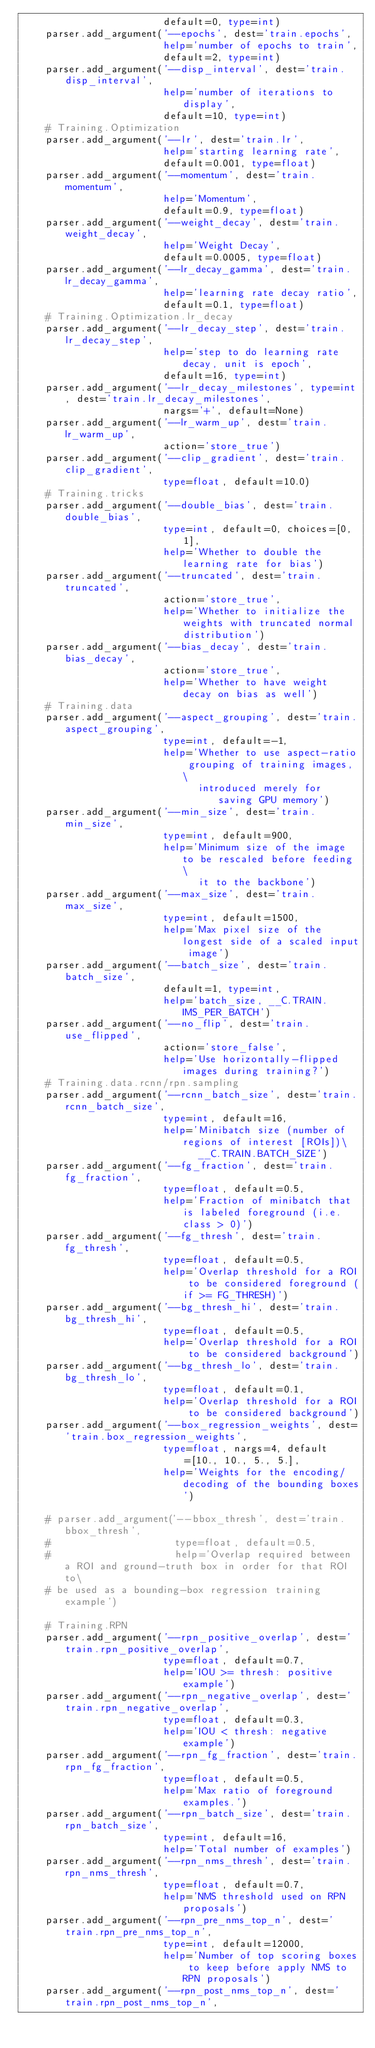Convert code to text. <code><loc_0><loc_0><loc_500><loc_500><_Python_>                        default=0, type=int)
    parser.add_argument('--epochs', dest='train.epochs',
                        help='number of epochs to train',
                        default=2, type=int)
    parser.add_argument('--disp_interval', dest='train.disp_interval',
                        help='number of iterations to display',
                        default=10, type=int)
    # Training.Optimization
    parser.add_argument('--lr', dest='train.lr',
                        help='starting learning rate',
                        default=0.001, type=float)
    parser.add_argument('--momentum', dest='train.momentum',
                        help='Momentum',
                        default=0.9, type=float)
    parser.add_argument('--weight_decay', dest='train.weight_decay',
                        help='Weight Decay',
                        default=0.0005, type=float)
    parser.add_argument('--lr_decay_gamma', dest='train.lr_decay_gamma',
                        help='learning rate decay ratio',
                        default=0.1, type=float)
    # Training.Optimization.lr_decay
    parser.add_argument('--lr_decay_step', dest='train.lr_decay_step',
                        help='step to do learning rate decay, unit is epoch',
                        default=16, type=int)
    parser.add_argument('--lr_decay_milestones', type=int, dest='train.lr_decay_milestones',
                        nargs='+', default=None)
    parser.add_argument('--lr_warm_up', dest='train.lr_warm_up',
                        action='store_true')
    parser.add_argument('--clip_gradient', dest='train.clip_gradient',
                        type=float, default=10.0)
    # Training.tricks
    parser.add_argument('--double_bias', dest='train.double_bias',
                        type=int, default=0, choices=[0, 1],
                        help='Whether to double the learning rate for bias')
    parser.add_argument('--truncated', dest='train.truncated',
                        action='store_true',
                        help='Whether to initialize the weights with truncated normal distribution')
    parser.add_argument('--bias_decay', dest='train.bias_decay',
                        action='store_true',
                        help='Whether to have weight decay on bias as well')
    # Training.data
    parser.add_argument('--aspect_grouping', dest='train.aspect_grouping',
                        type=int, default=-1,
                        help='Whether to use aspect-ratio grouping of training images, \
                              introduced merely for saving GPU memory')
    parser.add_argument('--min_size', dest='train.min_size',
                        type=int, default=900,
                        help='Minimum size of the image to be rescaled before feeding \
                              it to the backbone')
    parser.add_argument('--max_size', dest='train.max_size',
                        type=int, default=1500,
                        help='Max pixel size of the longest side of a scaled input image')
    parser.add_argument('--batch_size', dest='train.batch_size',
                        default=1, type=int,
                        help='batch_size, __C.TRAIN.IMS_PER_BATCH')
    parser.add_argument('--no_flip', dest='train.use_flipped',
                        action='store_false',
                        help='Use horizontally-flipped images during training?')
    # Training.data.rcnn/rpn.sampling
    parser.add_argument('--rcnn_batch_size', dest='train.rcnn_batch_size',
                        type=int, default=16,
                        help='Minibatch size (number of regions of interest [ROIs])\
                              __C.TRAIN.BATCH_SIZE')
    parser.add_argument('--fg_fraction', dest='train.fg_fraction',
                        type=float, default=0.5,
                        help='Fraction of minibatch that is labeled foreground (i.e. class > 0)')
    parser.add_argument('--fg_thresh', dest='train.fg_thresh',
                        type=float, default=0.5,
                        help='Overlap threshold for a ROI to be considered foreground (if >= FG_THRESH)')
    parser.add_argument('--bg_thresh_hi', dest='train.bg_thresh_hi',
                        type=float, default=0.5,
                        help='Overlap threshold for a ROI to be considered background')
    parser.add_argument('--bg_thresh_lo', dest='train.bg_thresh_lo',
                        type=float, default=0.1,
                        help='Overlap threshold for a ROI to be considered background')
    parser.add_argument('--box_regression_weights', dest='train.box_regression_weights',
                        type=float, nargs=4, default=[10., 10., 5., 5.],
                        help='Weights for the encoding/decoding of the bounding boxes')

    # parser.add_argument('--bbox_thresh', dest='train.bbox_thresh',
    #                     type=float, default=0.5,
    #                     help='Overlap required between a ROI and ground-truth box in order for that ROI to\
    # be used as a bounding-box regression training example')

    # Training.RPN
    parser.add_argument('--rpn_positive_overlap', dest='train.rpn_positive_overlap',
                        type=float, default=0.7,
                        help='IOU >= thresh: positive example')
    parser.add_argument('--rpn_negative_overlap', dest='train.rpn_negative_overlap',
                        type=float, default=0.3,
                        help='IOU < thresh: negative example')
    parser.add_argument('--rpn_fg_fraction', dest='train.rpn_fg_fraction',
                        type=float, default=0.5,
                        help='Max ratio of foreground examples.')
    parser.add_argument('--rpn_batch_size', dest='train.rpn_batch_size',
                        type=int, default=16,
                        help='Total number of examples')
    parser.add_argument('--rpn_nms_thresh', dest='train.rpn_nms_thresh',
                        type=float, default=0.7,
                        help='NMS threshold used on RPN proposals')
    parser.add_argument('--rpn_pre_nms_top_n', dest='train.rpn_pre_nms_top_n',
                        type=int, default=12000,
                        help='Number of top scoring boxes to keep before apply NMS to RPN proposals')
    parser.add_argument('--rpn_post_nms_top_n', dest='train.rpn_post_nms_top_n',</code> 